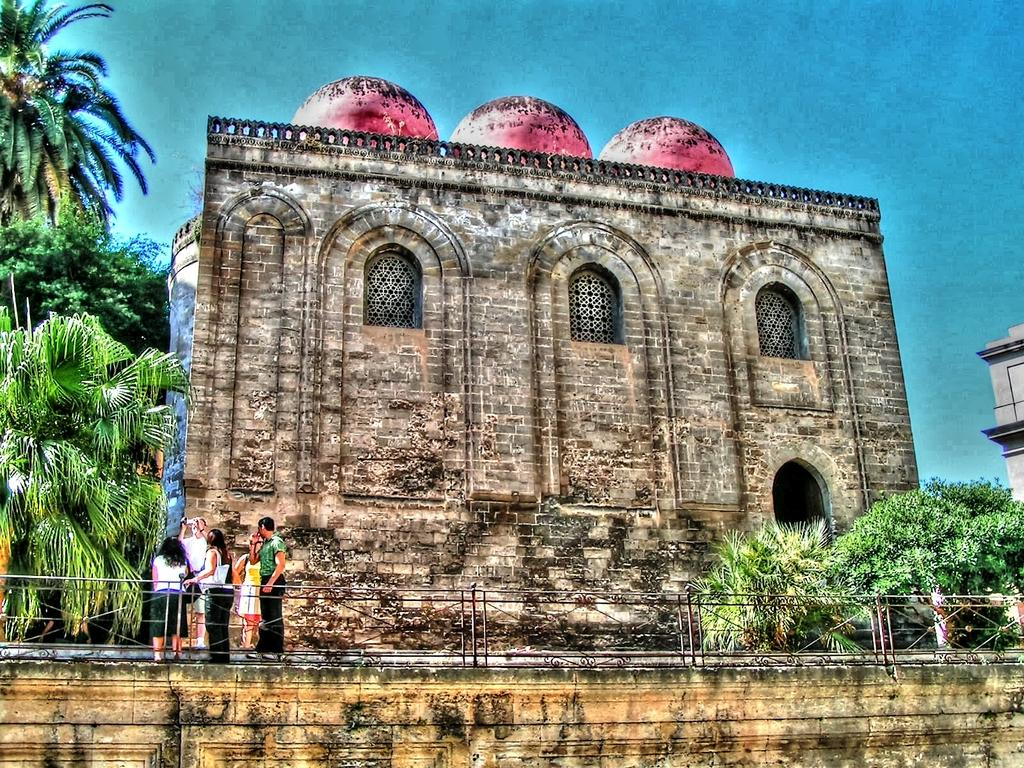How many people are in the image? There is a group of people standing in the image. What type of structure can be seen in the image? There are iron grills in the image. What type of vegetation is present in the image? There are trees in the image. What type of structure is visible in the background of the image? There is a building in the image. What is visible in the background of the image? The sky is visible in the background of the image. What type of hose is being used by the people in the image? There is no hose present in the image. What is the credit score of the person standing on the left in the image? There is no information about credit scores in the image. 